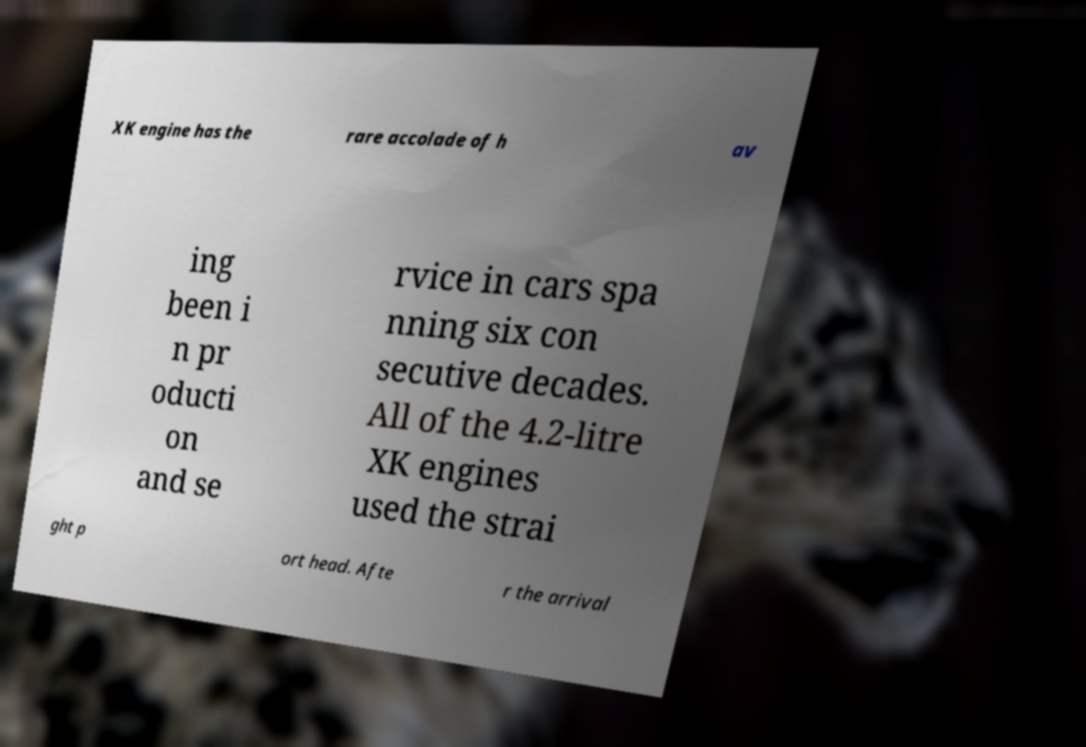Can you read and provide the text displayed in the image?This photo seems to have some interesting text. Can you extract and type it out for me? XK engine has the rare accolade of h av ing been i n pr oducti on and se rvice in cars spa nning six con secutive decades. All of the 4.2-litre XK engines used the strai ght p ort head. Afte r the arrival 